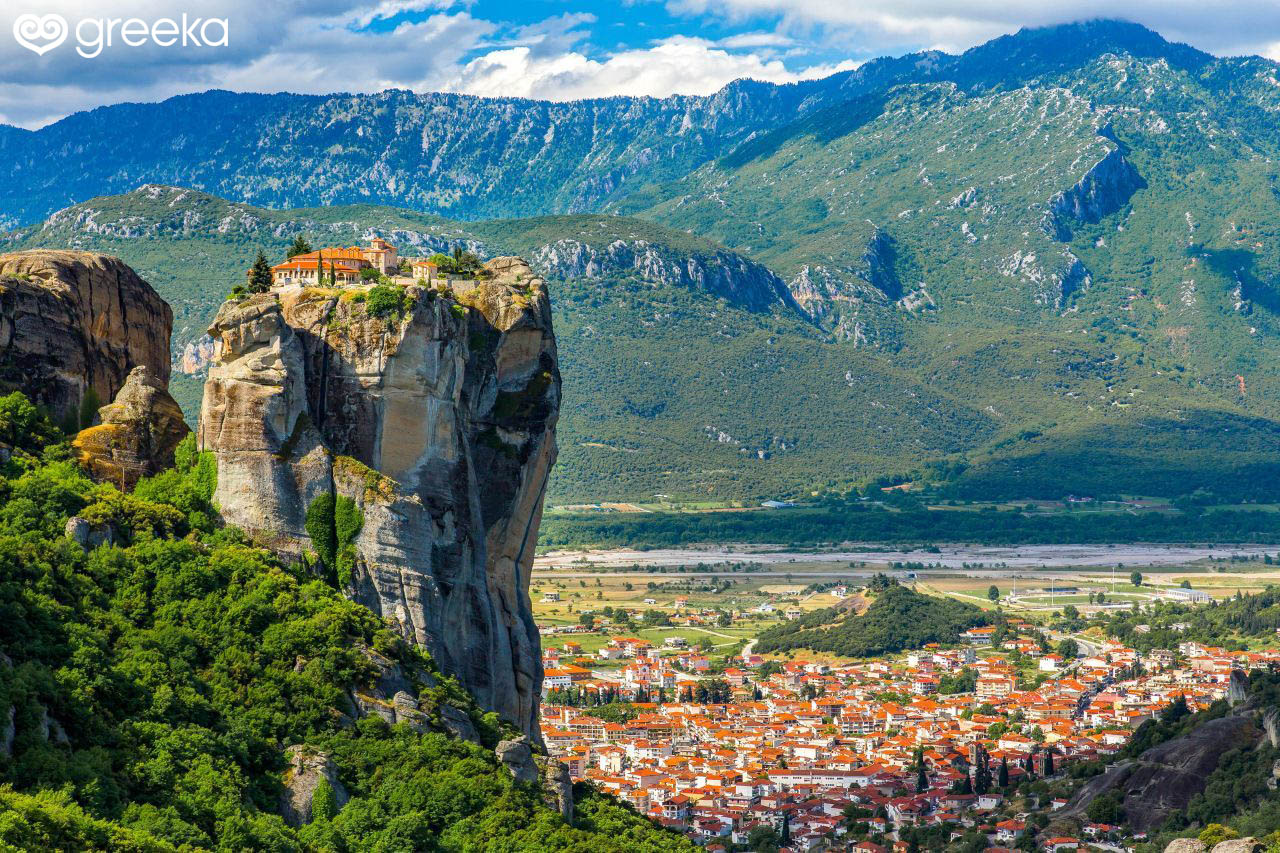What's a realistic scenario of a typical day in the monastery atop the rock formations? A typical day in the monastery atop the rock formations begins with the call to morning prayer before dawn. The monks gather in the ancient chapel, their chants reverberating off the stone walls. After a simple breakfast, they might engage in various tasks: some work in the gardens, tending to herbs and vegetables, while others engage in scribing texts or maintaining the monastery's structure. The quiet hours of the afternoon are reserved for personal study, meditation, and reflection. As evening approaches, the monks once again gather for prayer, followed by a communal meal, simple yet nourishing. The day ends with the setting sun casting its golden hues over the rugged landscape, every monk retreating to their quarters for rest. Where do the monks obtain their supplies from? The monks obtain their supplies from the town below through a combination of modern and traditional methods. Historically, supplies were hauled up using ropes and nets, but today, there are more practical methods such as small funiculars or stairways carved into the rock. They rely on the support of the local community, as well as donations from pilgrims and visitors. The monks might also cultivate their own vegetables and herbs within gardens in the monastery, sustaining themselves with the produce they grow. 